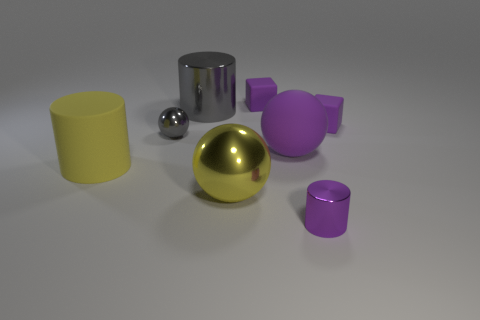What is the material of the cylinder that is the same color as the matte ball?
Keep it short and to the point. Metal. What material is the big yellow cylinder?
Provide a short and direct response. Rubber. The thing that is both on the right side of the large purple matte thing and behind the purple shiny cylinder is what color?
Your response must be concise. Purple. Is the number of small gray metal balls left of the tiny gray metallic sphere the same as the number of small gray spheres that are behind the yellow metal object?
Offer a terse response. No. There is a large cylinder that is made of the same material as the gray sphere; what color is it?
Ensure brevity in your answer.  Gray. Is the color of the big metal sphere the same as the large rubber thing that is left of the large yellow metal ball?
Ensure brevity in your answer.  Yes. Is there a big matte cylinder behind the ball to the left of the large metal thing behind the matte ball?
Your answer should be very brief. No. There is a large gray thing that is made of the same material as the big yellow ball; what shape is it?
Provide a succinct answer. Cylinder. Are there any other things that have the same shape as the yellow matte object?
Provide a succinct answer. Yes. The large yellow matte object has what shape?
Keep it short and to the point. Cylinder. 